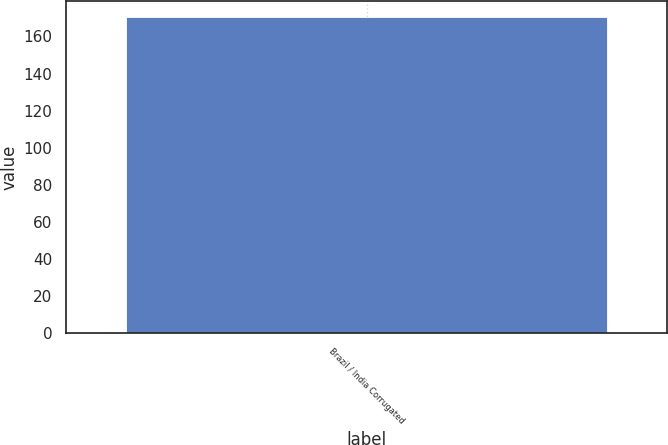<chart> <loc_0><loc_0><loc_500><loc_500><bar_chart><fcel>Brazil / India Corrugated<nl><fcel>170.5<nl></chart> 